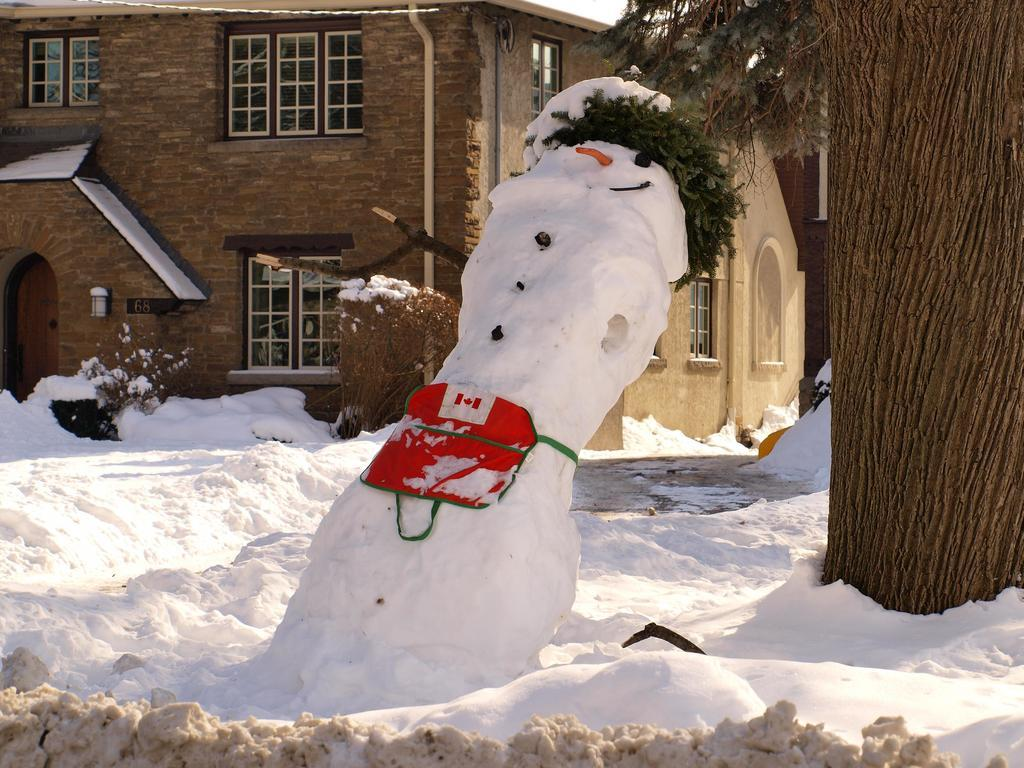What is the main feature in the foreground of the picture? There is snow in the foreground of the picture. What is the main feature in the center of the picture? There is a snowman in the center of the picture. What can be seen on the right side of the picture? There are trees on the right side of the picture. What is visible in the center of the background of the picture? There is a house in the center of the background of the picture. What sign is the woman holding in the picture? There is no woman or sign present in the picture; it features a snowman, snow, trees, and a house. What type of operation is being performed on the snowman in the picture? There is no operation being performed on the snowman in the picture; it is a static snowman. 